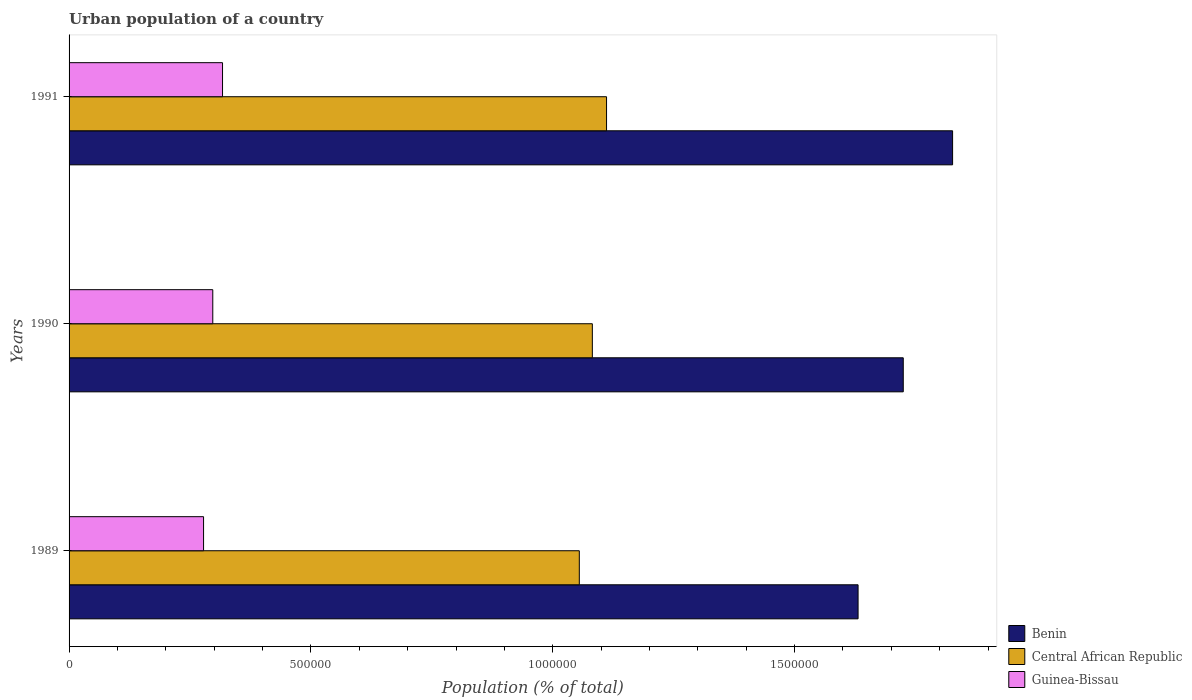How many different coloured bars are there?
Your answer should be compact. 3. Are the number of bars per tick equal to the number of legend labels?
Your response must be concise. Yes. Are the number of bars on each tick of the Y-axis equal?
Provide a short and direct response. Yes. How many bars are there on the 1st tick from the top?
Provide a succinct answer. 3. In how many cases, is the number of bars for a given year not equal to the number of legend labels?
Your answer should be compact. 0. What is the urban population in Central African Republic in 1989?
Your answer should be compact. 1.05e+06. Across all years, what is the maximum urban population in Benin?
Offer a very short reply. 1.83e+06. Across all years, what is the minimum urban population in Central African Republic?
Give a very brief answer. 1.05e+06. What is the total urban population in Central African Republic in the graph?
Your answer should be very brief. 3.25e+06. What is the difference between the urban population in Central African Republic in 1989 and that in 1991?
Offer a terse response. -5.63e+04. What is the difference between the urban population in Guinea-Bissau in 1990 and the urban population in Central African Republic in 1991?
Ensure brevity in your answer.  -8.14e+05. What is the average urban population in Benin per year?
Give a very brief answer. 1.73e+06. In the year 1990, what is the difference between the urban population in Guinea-Bissau and urban population in Central African Republic?
Offer a terse response. -7.85e+05. What is the ratio of the urban population in Guinea-Bissau in 1989 to that in 1990?
Offer a very short reply. 0.94. Is the urban population in Guinea-Bissau in 1989 less than that in 1991?
Offer a very short reply. Yes. What is the difference between the highest and the second highest urban population in Central African Republic?
Offer a terse response. 2.94e+04. What is the difference between the highest and the lowest urban population in Central African Republic?
Provide a succinct answer. 5.63e+04. In how many years, is the urban population in Benin greater than the average urban population in Benin taken over all years?
Keep it short and to the point. 1. What does the 3rd bar from the top in 1991 represents?
Offer a terse response. Benin. What does the 3rd bar from the bottom in 1990 represents?
Your response must be concise. Guinea-Bissau. How many bars are there?
Provide a succinct answer. 9. How many years are there in the graph?
Keep it short and to the point. 3. What is the difference between two consecutive major ticks on the X-axis?
Offer a very short reply. 5.00e+05. Does the graph contain grids?
Keep it short and to the point. No. Where does the legend appear in the graph?
Keep it short and to the point. Bottom right. How are the legend labels stacked?
Keep it short and to the point. Vertical. What is the title of the graph?
Provide a short and direct response. Urban population of a country. What is the label or title of the X-axis?
Offer a very short reply. Population (% of total). What is the Population (% of total) in Benin in 1989?
Your answer should be very brief. 1.63e+06. What is the Population (% of total) of Central African Republic in 1989?
Provide a short and direct response. 1.05e+06. What is the Population (% of total) in Guinea-Bissau in 1989?
Keep it short and to the point. 2.78e+05. What is the Population (% of total) in Benin in 1990?
Provide a short and direct response. 1.72e+06. What is the Population (% of total) of Central African Republic in 1990?
Make the answer very short. 1.08e+06. What is the Population (% of total) in Guinea-Bissau in 1990?
Give a very brief answer. 2.97e+05. What is the Population (% of total) in Benin in 1991?
Your answer should be compact. 1.83e+06. What is the Population (% of total) in Central African Republic in 1991?
Give a very brief answer. 1.11e+06. What is the Population (% of total) of Guinea-Bissau in 1991?
Keep it short and to the point. 3.17e+05. Across all years, what is the maximum Population (% of total) of Benin?
Ensure brevity in your answer.  1.83e+06. Across all years, what is the maximum Population (% of total) in Central African Republic?
Keep it short and to the point. 1.11e+06. Across all years, what is the maximum Population (% of total) in Guinea-Bissau?
Provide a succinct answer. 3.17e+05. Across all years, what is the minimum Population (% of total) in Benin?
Offer a very short reply. 1.63e+06. Across all years, what is the minimum Population (% of total) of Central African Republic?
Provide a short and direct response. 1.05e+06. Across all years, what is the minimum Population (% of total) of Guinea-Bissau?
Give a very brief answer. 2.78e+05. What is the total Population (% of total) of Benin in the graph?
Give a very brief answer. 5.18e+06. What is the total Population (% of total) in Central African Republic in the graph?
Your response must be concise. 3.25e+06. What is the total Population (% of total) in Guinea-Bissau in the graph?
Give a very brief answer. 8.92e+05. What is the difference between the Population (% of total) in Benin in 1989 and that in 1990?
Provide a short and direct response. -9.34e+04. What is the difference between the Population (% of total) in Central African Republic in 1989 and that in 1990?
Your answer should be very brief. -2.69e+04. What is the difference between the Population (% of total) of Guinea-Bissau in 1989 and that in 1990?
Ensure brevity in your answer.  -1.91e+04. What is the difference between the Population (% of total) of Benin in 1989 and that in 1991?
Give a very brief answer. -1.95e+05. What is the difference between the Population (% of total) of Central African Republic in 1989 and that in 1991?
Your answer should be very brief. -5.63e+04. What is the difference between the Population (% of total) in Guinea-Bissau in 1989 and that in 1991?
Offer a terse response. -3.92e+04. What is the difference between the Population (% of total) in Benin in 1990 and that in 1991?
Your answer should be very brief. -1.02e+05. What is the difference between the Population (% of total) in Central African Republic in 1990 and that in 1991?
Make the answer very short. -2.94e+04. What is the difference between the Population (% of total) of Guinea-Bissau in 1990 and that in 1991?
Offer a terse response. -2.01e+04. What is the difference between the Population (% of total) in Benin in 1989 and the Population (% of total) in Central African Republic in 1990?
Offer a very short reply. 5.49e+05. What is the difference between the Population (% of total) of Benin in 1989 and the Population (% of total) of Guinea-Bissau in 1990?
Offer a very short reply. 1.33e+06. What is the difference between the Population (% of total) in Central African Republic in 1989 and the Population (% of total) in Guinea-Bissau in 1990?
Provide a short and direct response. 7.58e+05. What is the difference between the Population (% of total) of Benin in 1989 and the Population (% of total) of Central African Republic in 1991?
Offer a very short reply. 5.20e+05. What is the difference between the Population (% of total) of Benin in 1989 and the Population (% of total) of Guinea-Bissau in 1991?
Your answer should be very brief. 1.31e+06. What is the difference between the Population (% of total) of Central African Republic in 1989 and the Population (% of total) of Guinea-Bissau in 1991?
Give a very brief answer. 7.38e+05. What is the difference between the Population (% of total) of Benin in 1990 and the Population (% of total) of Central African Republic in 1991?
Give a very brief answer. 6.13e+05. What is the difference between the Population (% of total) of Benin in 1990 and the Population (% of total) of Guinea-Bissau in 1991?
Your answer should be compact. 1.41e+06. What is the difference between the Population (% of total) in Central African Republic in 1990 and the Population (% of total) in Guinea-Bissau in 1991?
Your answer should be very brief. 7.65e+05. What is the average Population (% of total) of Benin per year?
Keep it short and to the point. 1.73e+06. What is the average Population (% of total) in Central African Republic per year?
Provide a succinct answer. 1.08e+06. What is the average Population (% of total) in Guinea-Bissau per year?
Your answer should be very brief. 2.97e+05. In the year 1989, what is the difference between the Population (% of total) of Benin and Population (% of total) of Central African Republic?
Your response must be concise. 5.76e+05. In the year 1989, what is the difference between the Population (% of total) in Benin and Population (% of total) in Guinea-Bissau?
Give a very brief answer. 1.35e+06. In the year 1989, what is the difference between the Population (% of total) in Central African Republic and Population (% of total) in Guinea-Bissau?
Make the answer very short. 7.77e+05. In the year 1990, what is the difference between the Population (% of total) in Benin and Population (% of total) in Central African Republic?
Your answer should be very brief. 6.43e+05. In the year 1990, what is the difference between the Population (% of total) in Benin and Population (% of total) in Guinea-Bissau?
Make the answer very short. 1.43e+06. In the year 1990, what is the difference between the Population (% of total) in Central African Republic and Population (% of total) in Guinea-Bissau?
Keep it short and to the point. 7.85e+05. In the year 1991, what is the difference between the Population (% of total) in Benin and Population (% of total) in Central African Republic?
Give a very brief answer. 7.15e+05. In the year 1991, what is the difference between the Population (% of total) of Benin and Population (% of total) of Guinea-Bissau?
Provide a succinct answer. 1.51e+06. In the year 1991, what is the difference between the Population (% of total) of Central African Republic and Population (% of total) of Guinea-Bissau?
Your response must be concise. 7.94e+05. What is the ratio of the Population (% of total) of Benin in 1989 to that in 1990?
Make the answer very short. 0.95. What is the ratio of the Population (% of total) in Central African Republic in 1989 to that in 1990?
Offer a very short reply. 0.98. What is the ratio of the Population (% of total) of Guinea-Bissau in 1989 to that in 1990?
Your answer should be compact. 0.94. What is the ratio of the Population (% of total) of Benin in 1989 to that in 1991?
Your answer should be very brief. 0.89. What is the ratio of the Population (% of total) in Central African Republic in 1989 to that in 1991?
Your response must be concise. 0.95. What is the ratio of the Population (% of total) in Guinea-Bissau in 1989 to that in 1991?
Provide a short and direct response. 0.88. What is the ratio of the Population (% of total) in Benin in 1990 to that in 1991?
Offer a terse response. 0.94. What is the ratio of the Population (% of total) of Central African Republic in 1990 to that in 1991?
Give a very brief answer. 0.97. What is the ratio of the Population (% of total) in Guinea-Bissau in 1990 to that in 1991?
Your response must be concise. 0.94. What is the difference between the highest and the second highest Population (% of total) of Benin?
Your answer should be compact. 1.02e+05. What is the difference between the highest and the second highest Population (% of total) of Central African Republic?
Your response must be concise. 2.94e+04. What is the difference between the highest and the second highest Population (% of total) in Guinea-Bissau?
Ensure brevity in your answer.  2.01e+04. What is the difference between the highest and the lowest Population (% of total) of Benin?
Keep it short and to the point. 1.95e+05. What is the difference between the highest and the lowest Population (% of total) of Central African Republic?
Make the answer very short. 5.63e+04. What is the difference between the highest and the lowest Population (% of total) of Guinea-Bissau?
Your answer should be compact. 3.92e+04. 